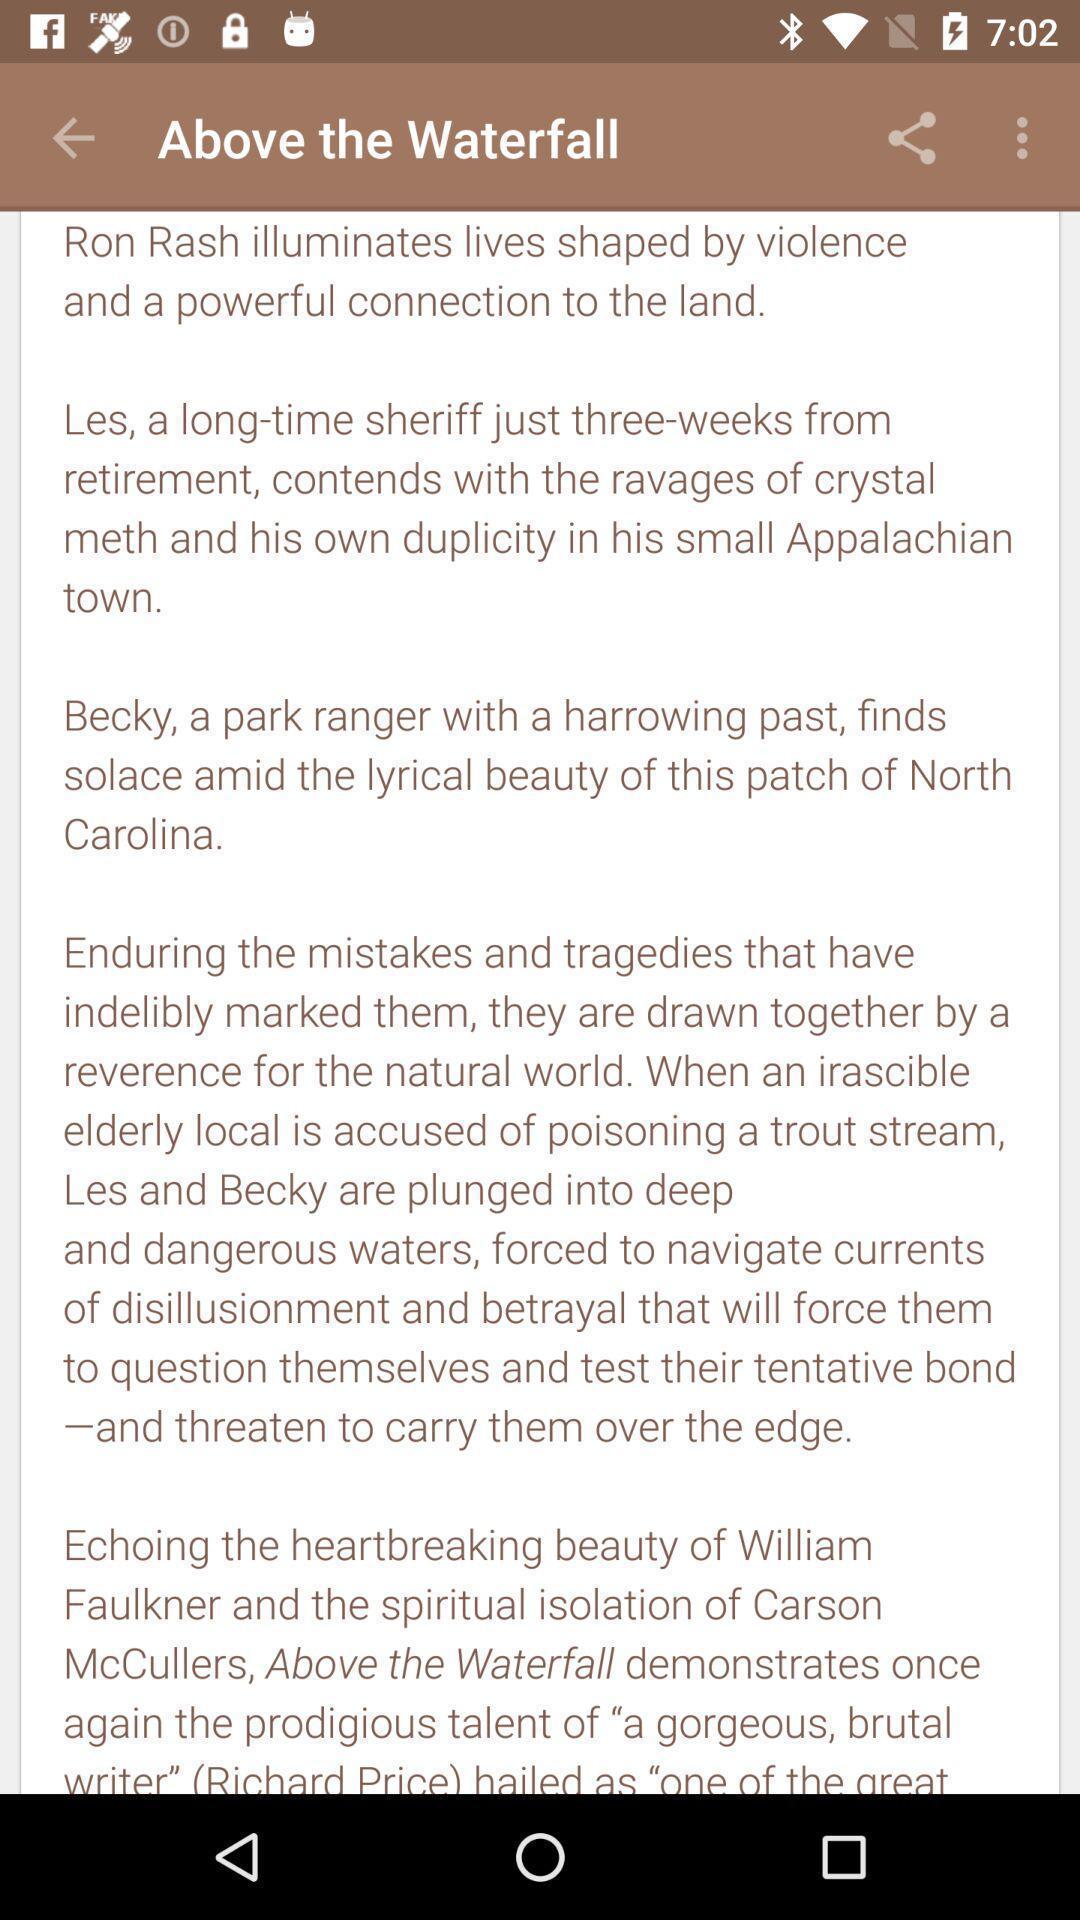Provide a detailed account of this screenshot. Screen shows summary of ebooks and audio books. 